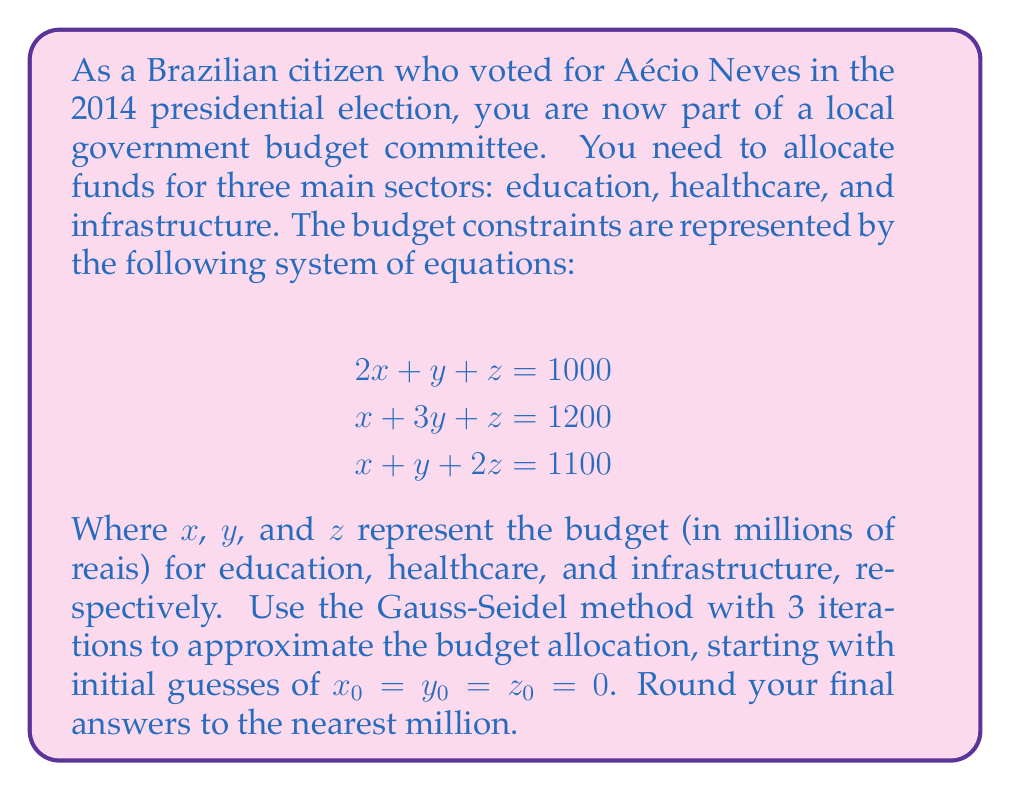Teach me how to tackle this problem. To solve this system using the Gauss-Seidel method, we'll rearrange the equations to isolate each variable:

$$\begin{align}
x &= \frac{1000 - y - z}{2} \\
y &= \frac{1200 - x - z}{3} \\
z &= \frac{1100 - x - y}{2}
\end{align}$$

Now, we'll perform 3 iterations:

Iteration 1:
$$\begin{align}
x_1 &= \frac{1000 - 0 - 0}{2} = 500 \\
y_1 &= \frac{1200 - 500 - 0}{3} = 233.33 \\
z_1 &= \frac{1100 - 500 - 233.33}{2} = 183.33
\end{align}$$

Iteration 2:
$$\begin{align}
x_2 &= \frac{1000 - 233.33 - 183.33}{2} = 291.67 \\
y_2 &= \frac{1200 - 291.67 - 183.33}{3} = 241.67 \\
z_2 &= \frac{1100 - 291.67 - 241.67}{2} = 283.33
\end{align}$$

Iteration 3:
$$\begin{align}
x_3 &= \frac{1000 - 241.67 - 283.33}{2} = 237.50 \\
y_3 &= \frac{1200 - 237.50 - 283.33}{3} = 226.39 \\
z_3 &= \frac{1100 - 237.50 - 226.39}{2} = 318.06
\end{align}$$

Rounding to the nearest million:
$x \approx 238$ million reais
$y \approx 226$ million reais
$z \approx 318$ million reais
Answer: Education: R$238 million, Healthcare: R$226 million, Infrastructure: R$318 million 